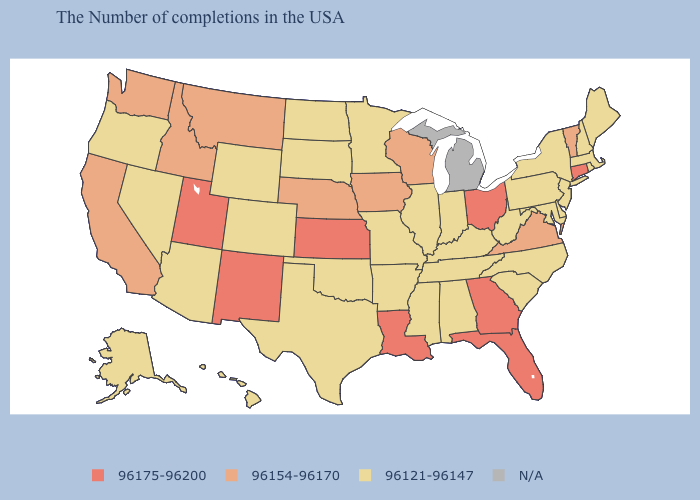Among the states that border Minnesota , does North Dakota have the highest value?
Be succinct. No. What is the value of Alaska?
Quick response, please. 96121-96147. Does the first symbol in the legend represent the smallest category?
Answer briefly. No. What is the highest value in the USA?
Quick response, please. 96175-96200. Among the states that border Minnesota , does Wisconsin have the highest value?
Keep it brief. Yes. Name the states that have a value in the range 96154-96170?
Be succinct. Vermont, Virginia, Wisconsin, Iowa, Nebraska, Montana, Idaho, California, Washington. Does South Dakota have the lowest value in the USA?
Write a very short answer. Yes. Does the first symbol in the legend represent the smallest category?
Write a very short answer. No. Which states have the lowest value in the Northeast?
Concise answer only. Maine, Massachusetts, Rhode Island, New Hampshire, New York, New Jersey, Pennsylvania. Does the map have missing data?
Keep it brief. Yes. Does the map have missing data?
Be succinct. Yes. What is the lowest value in the Northeast?
Give a very brief answer. 96121-96147. What is the highest value in states that border Montana?
Concise answer only. 96154-96170. Does North Carolina have the lowest value in the USA?
Short answer required. Yes. 